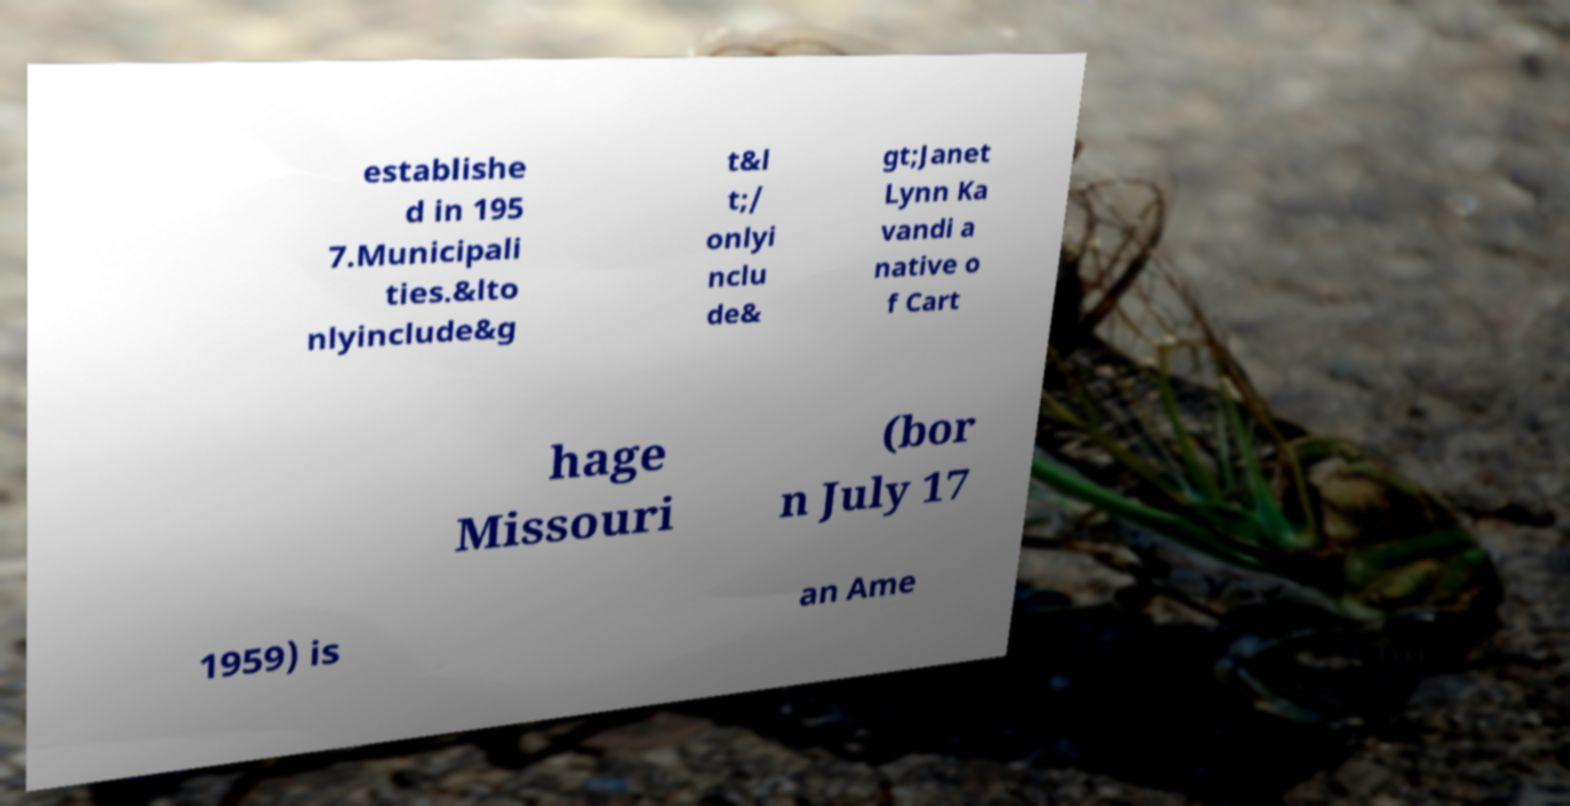For documentation purposes, I need the text within this image transcribed. Could you provide that? establishe d in 195 7.Municipali ties.&lto nlyinclude&g t&l t;/ onlyi nclu de& gt;Janet Lynn Ka vandi a native o f Cart hage Missouri (bor n July 17 1959) is an Ame 